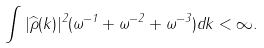Convert formula to latex. <formula><loc_0><loc_0><loc_500><loc_500>\int | \widehat { \rho } ( k ) | ^ { 2 } ( \omega ^ { - 1 } + \omega ^ { - 2 } + \omega ^ { - 3 } ) d k < \infty .</formula> 